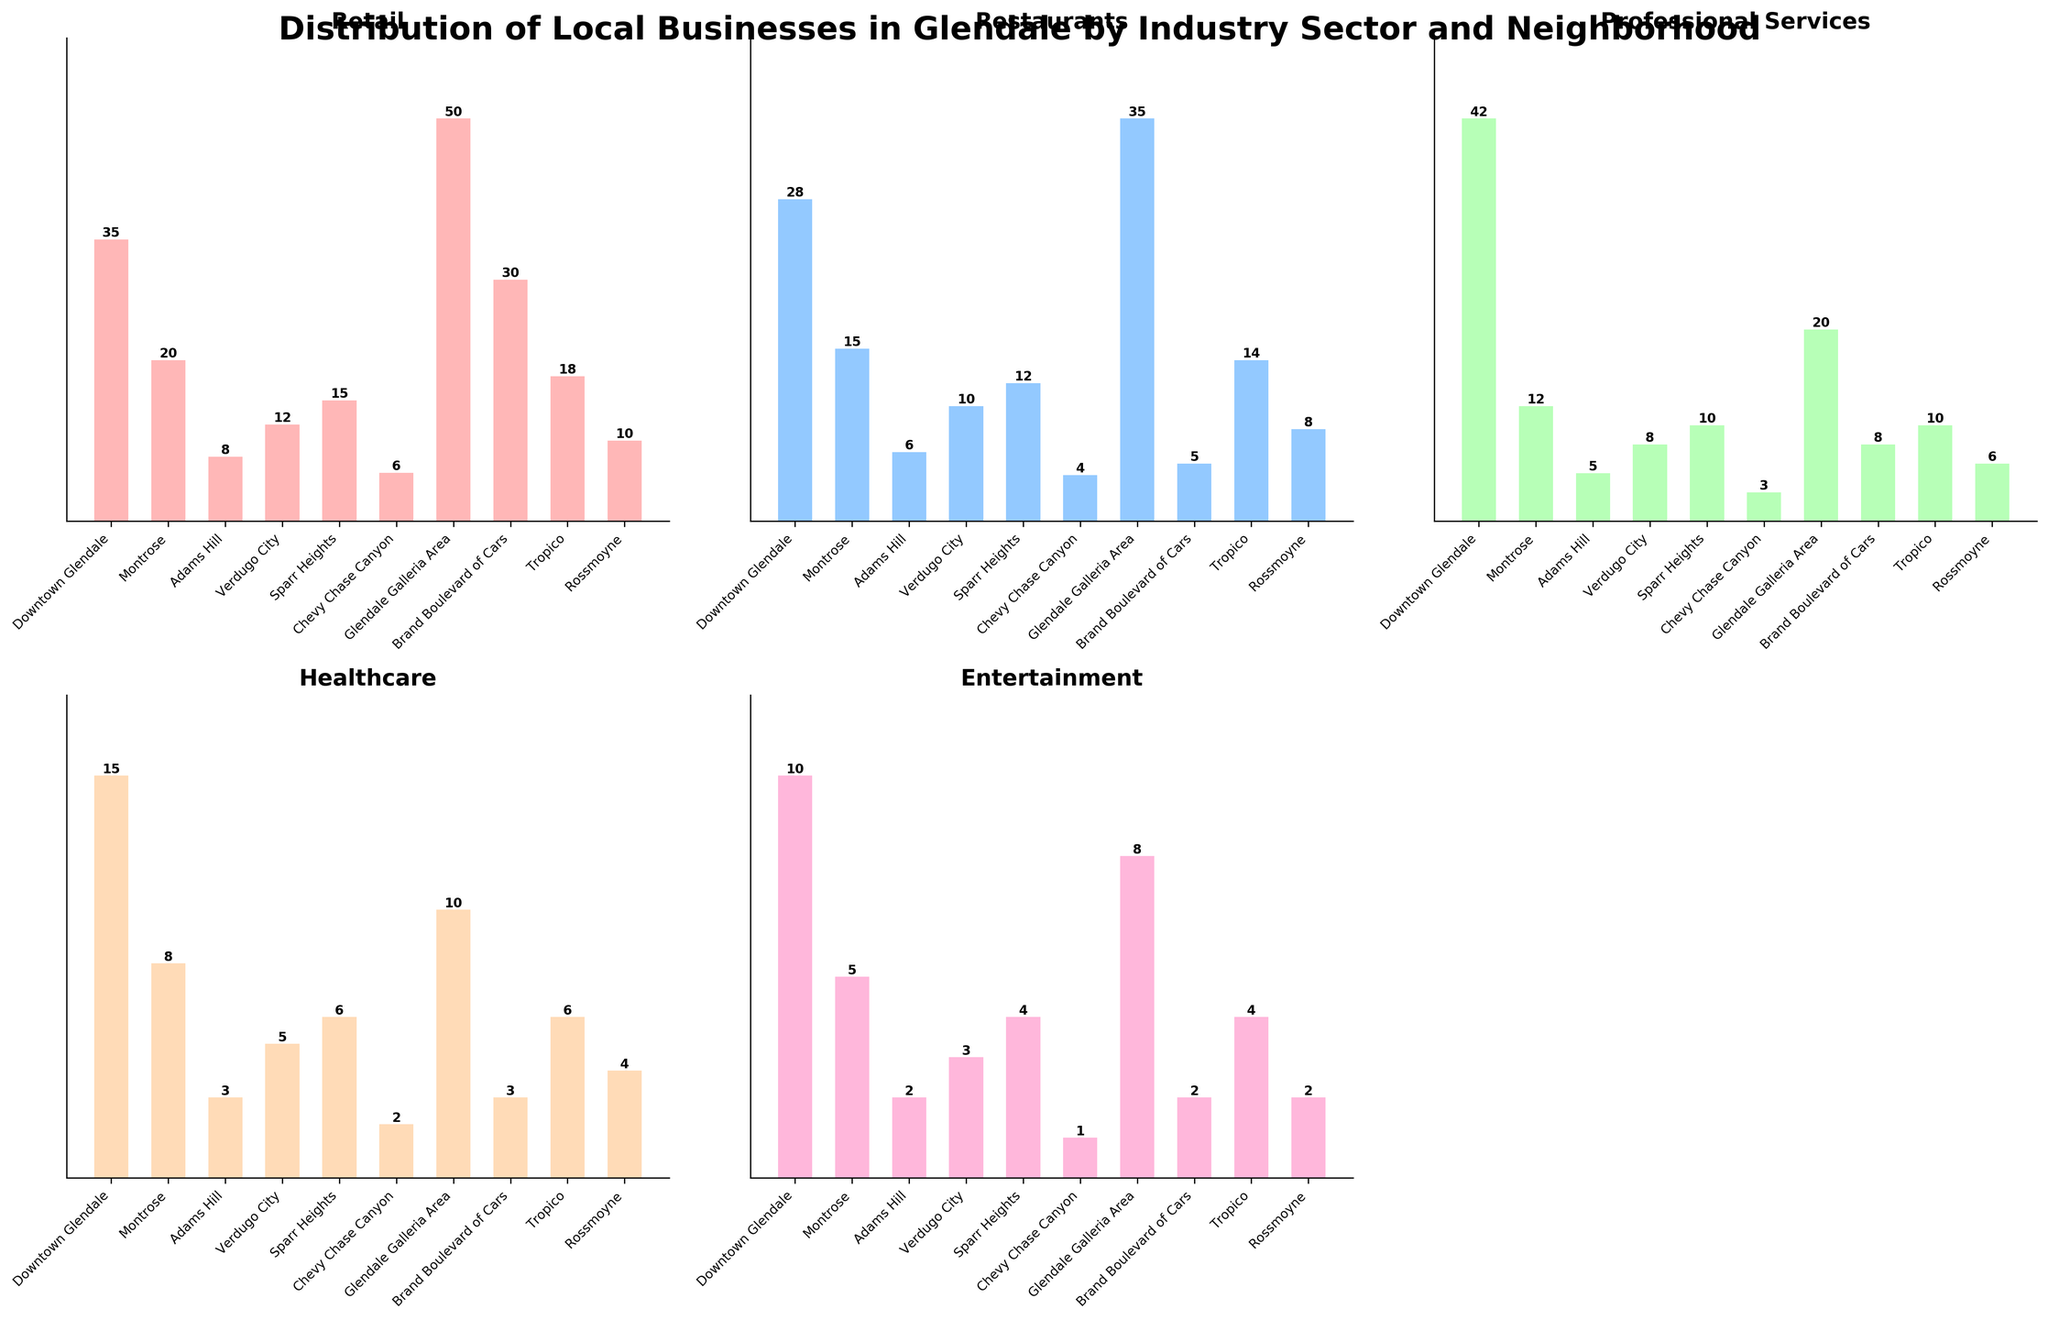How many retail businesses are there in Glendale Galleria Area? Locate the Retail subplot and look for the bar corresponding to Glendale Galleria Area. The height of that bar is 50.
Answer: 50 Which neighborhood has the fewest healthcare businesses? Locate the Healthcare subplot and identify the shortest bar. The shortest bar is in Chevy Chase Canyon, which has 2 businesses.
Answer: Chevy Chase Canyon How many more restaurants are there in Downtown Glendale compared to Adams Hill? Locate both the Downtown Glendale and Adams Hill bars in the Restaurants subplot. Downtown Glendale has 28 restaurants and Adams Hill has 6. The difference is 28 - 6 = 22.
Answer: 22 Which industry sector has the highest number of businesses across all neighborhoods combined? Look for the overall trend across all subplots and compare the heights of the tallest bars in each subplot. The Retail subplot has the tallest individual bars, indicating more retail businesses overall.
Answer: Retail What's the total number of entertainment businesses in Montrose, Sparr Heights, and Tropico combined? Locate the Entertainment subplot and add the values from Montrose (5), Sparr Heights (4), and Tropico (4). The sum is 5 + 4 + 4 = 13.
Answer: 13 In which neighborhood do retail businesses outnumber professional services by the greatest margin? Compare the differences between Retail and Professional Services subplots for all neighborhoods. The greatest margin is in Brand Boulevard of Cars, where Retail (30) outnumbers Professional Services (8) by 22.
Answer: Brand Boulevard of Cars Is the average number of healthcare businesses greater in Downtown Glendale or Montrose? For Downtown Glendale, the number of healthcare businesses is 15, and for Montrose, it is 8. The average is calculated by dividing the total number by one (since each is just a single number), resulting in 15 for Downtown Glendale and 8 for Montrose. Thus, Downtown Glendale has a higher average (15).
Answer: Downtown Glendale What's the average number of retail businesses per neighborhood? Sum the retail businesses across all neighborhoods and divide by the number of neighborhoods. The total sum is 194. There are 10 neighborhoods. The average is 194 / 10 = 19.4.
Answer: 19.4 Which neighborhood has an equal number of professional services and healthcare businesses? Locate the Professional Services and Healthcare subplots and identify the neighborhood where both bars are of equal height. Tropico has equal numbers with 10 each.
Answer: Tropico 